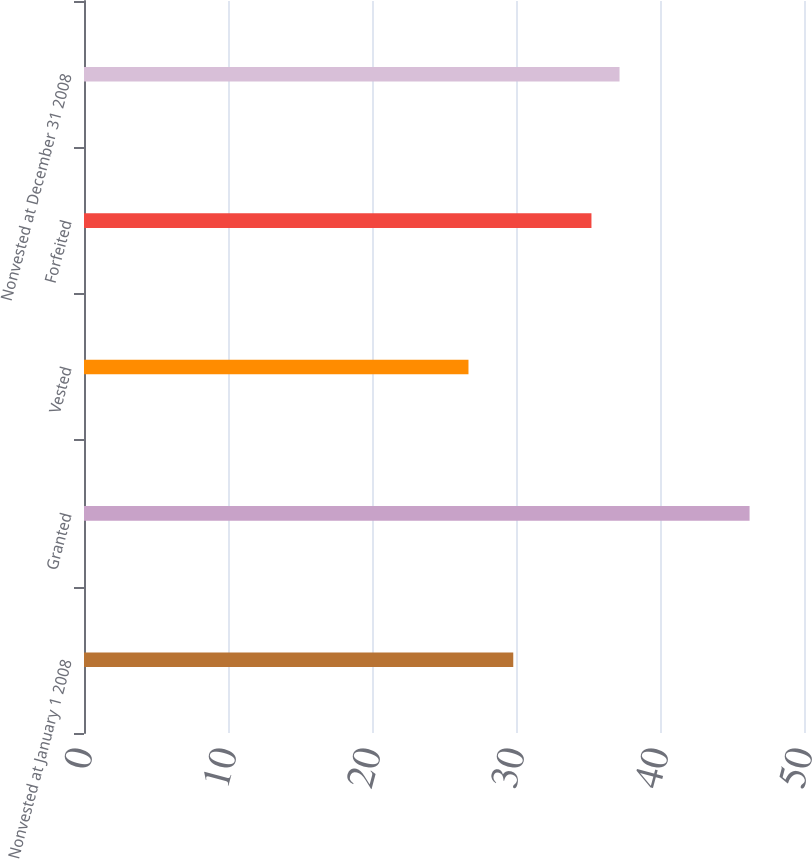Convert chart to OTSL. <chart><loc_0><loc_0><loc_500><loc_500><bar_chart><fcel>Nonvested at January 1 2008<fcel>Granted<fcel>Vested<fcel>Forfeited<fcel>Nonvested at December 31 2008<nl><fcel>29.81<fcel>46.22<fcel>26.7<fcel>35.24<fcel>37.19<nl></chart> 